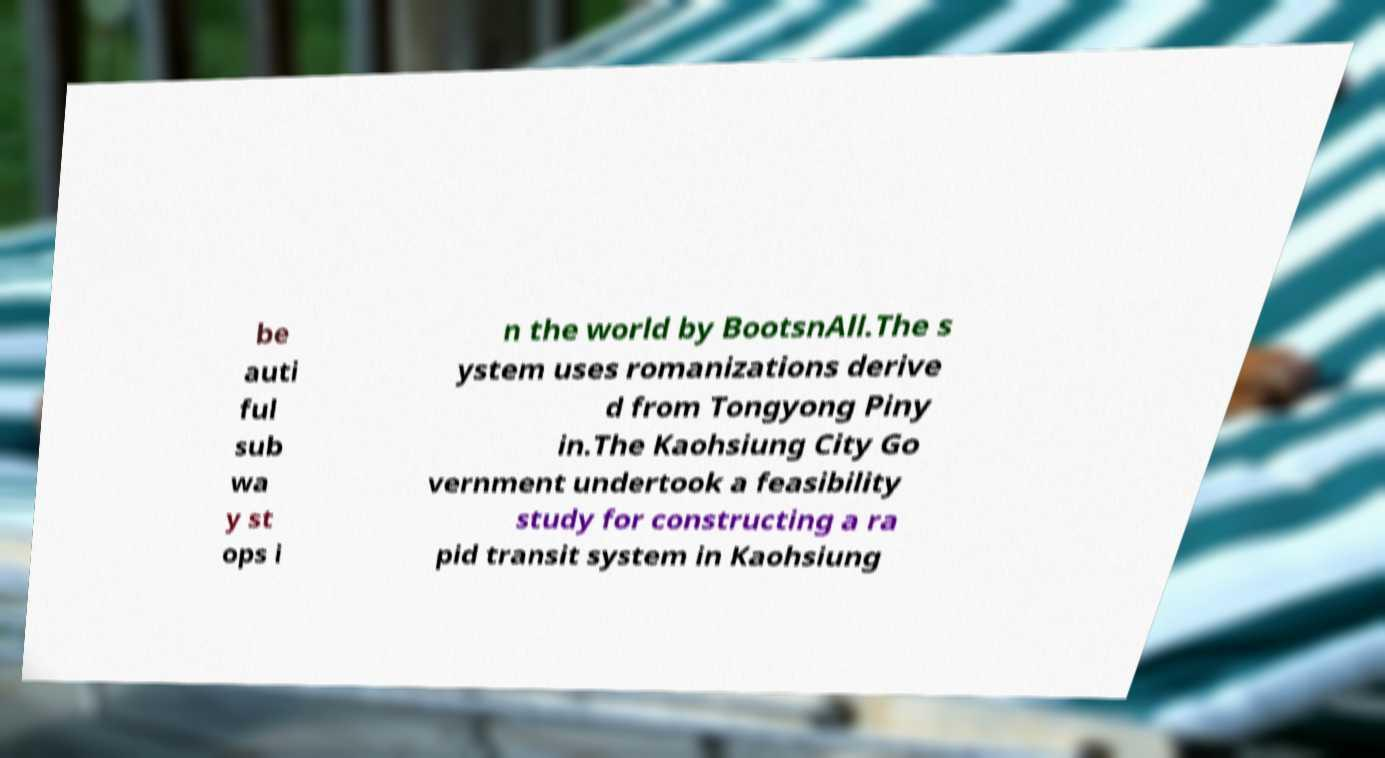Please identify and transcribe the text found in this image. be auti ful sub wa y st ops i n the world by BootsnAll.The s ystem uses romanizations derive d from Tongyong Piny in.The Kaohsiung City Go vernment undertook a feasibility study for constructing a ra pid transit system in Kaohsiung 